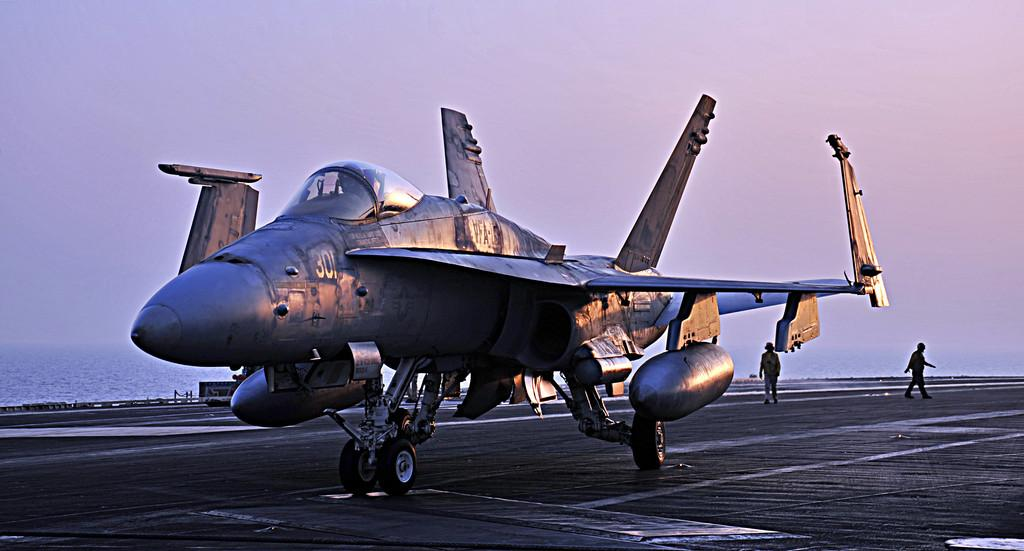What is the main subject of the image? There is an aircraft in the image. Can you describe any other elements in the background? Yes, there are two people walking in the background. What natural element can be seen in the image? There is water visible in the image. How would you describe the color of the sky in the image? The sky is a combination of white and blue colors. What verse is being recited by the queen in the image? There is no queen or verse present in the image. 